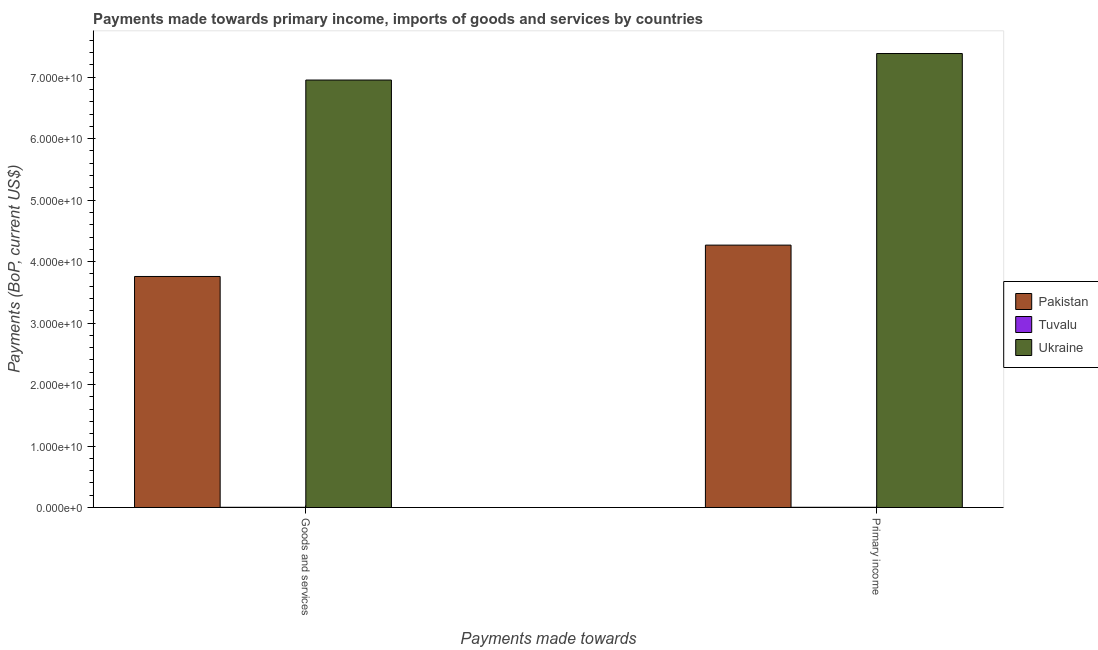How many different coloured bars are there?
Ensure brevity in your answer.  3. Are the number of bars per tick equal to the number of legend labels?
Provide a succinct answer. Yes. How many bars are there on the 1st tick from the left?
Make the answer very short. 3. What is the label of the 1st group of bars from the left?
Provide a succinct answer. Goods and services. What is the payments made towards primary income in Ukraine?
Provide a short and direct response. 7.39e+1. Across all countries, what is the maximum payments made towards goods and services?
Offer a terse response. 6.95e+1. Across all countries, what is the minimum payments made towards primary income?
Offer a very short reply. 3.24e+07. In which country was the payments made towards goods and services maximum?
Provide a succinct answer. Ukraine. In which country was the payments made towards primary income minimum?
Offer a terse response. Tuvalu. What is the total payments made towards goods and services in the graph?
Make the answer very short. 1.07e+11. What is the difference between the payments made towards primary income in Tuvalu and that in Pakistan?
Make the answer very short. -4.27e+1. What is the difference between the payments made towards goods and services in Tuvalu and the payments made towards primary income in Ukraine?
Make the answer very short. -7.38e+1. What is the average payments made towards primary income per country?
Your response must be concise. 3.89e+1. What is the difference between the payments made towards primary income and payments made towards goods and services in Tuvalu?
Your answer should be compact. 7.97e+05. What is the ratio of the payments made towards primary income in Pakistan to that in Tuvalu?
Your answer should be very brief. 1316.66. Is the payments made towards primary income in Tuvalu less than that in Ukraine?
Offer a very short reply. Yes. What does the 3rd bar from the left in Goods and services represents?
Give a very brief answer. Ukraine. What does the 1st bar from the right in Goods and services represents?
Your answer should be very brief. Ukraine. How many countries are there in the graph?
Your response must be concise. 3. What is the difference between two consecutive major ticks on the Y-axis?
Your response must be concise. 1.00e+1. Are the values on the major ticks of Y-axis written in scientific E-notation?
Your response must be concise. Yes. Does the graph contain any zero values?
Ensure brevity in your answer.  No. Does the graph contain grids?
Provide a succinct answer. No. How many legend labels are there?
Ensure brevity in your answer.  3. What is the title of the graph?
Your answer should be very brief. Payments made towards primary income, imports of goods and services by countries. Does "St. Kitts and Nevis" appear as one of the legend labels in the graph?
Ensure brevity in your answer.  No. What is the label or title of the X-axis?
Offer a terse response. Payments made towards. What is the label or title of the Y-axis?
Keep it short and to the point. Payments (BoP, current US$). What is the Payments (BoP, current US$) in Pakistan in Goods and services?
Offer a terse response. 3.76e+1. What is the Payments (BoP, current US$) in Tuvalu in Goods and services?
Keep it short and to the point. 3.16e+07. What is the Payments (BoP, current US$) in Ukraine in Goods and services?
Ensure brevity in your answer.  6.95e+1. What is the Payments (BoP, current US$) in Pakistan in Primary income?
Make the answer very short. 4.27e+1. What is the Payments (BoP, current US$) of Tuvalu in Primary income?
Offer a very short reply. 3.24e+07. What is the Payments (BoP, current US$) in Ukraine in Primary income?
Keep it short and to the point. 7.39e+1. Across all Payments made towards, what is the maximum Payments (BoP, current US$) of Pakistan?
Ensure brevity in your answer.  4.27e+1. Across all Payments made towards, what is the maximum Payments (BoP, current US$) in Tuvalu?
Your answer should be compact. 3.24e+07. Across all Payments made towards, what is the maximum Payments (BoP, current US$) in Ukraine?
Ensure brevity in your answer.  7.39e+1. Across all Payments made towards, what is the minimum Payments (BoP, current US$) of Pakistan?
Give a very brief answer. 3.76e+1. Across all Payments made towards, what is the minimum Payments (BoP, current US$) of Tuvalu?
Provide a short and direct response. 3.16e+07. Across all Payments made towards, what is the minimum Payments (BoP, current US$) of Ukraine?
Keep it short and to the point. 6.95e+1. What is the total Payments (BoP, current US$) in Pakistan in the graph?
Give a very brief answer. 8.03e+1. What is the total Payments (BoP, current US$) of Tuvalu in the graph?
Provide a succinct answer. 6.40e+07. What is the total Payments (BoP, current US$) in Ukraine in the graph?
Ensure brevity in your answer.  1.43e+11. What is the difference between the Payments (BoP, current US$) in Pakistan in Goods and services and that in Primary income?
Make the answer very short. -5.10e+09. What is the difference between the Payments (BoP, current US$) of Tuvalu in Goods and services and that in Primary income?
Give a very brief answer. -7.97e+05. What is the difference between the Payments (BoP, current US$) of Ukraine in Goods and services and that in Primary income?
Provide a short and direct response. -4.32e+09. What is the difference between the Payments (BoP, current US$) in Pakistan in Goods and services and the Payments (BoP, current US$) in Tuvalu in Primary income?
Keep it short and to the point. 3.76e+1. What is the difference between the Payments (BoP, current US$) of Pakistan in Goods and services and the Payments (BoP, current US$) of Ukraine in Primary income?
Your response must be concise. -3.63e+1. What is the difference between the Payments (BoP, current US$) in Tuvalu in Goods and services and the Payments (BoP, current US$) in Ukraine in Primary income?
Provide a succinct answer. -7.38e+1. What is the average Payments (BoP, current US$) in Pakistan per Payments made towards?
Your response must be concise. 4.01e+1. What is the average Payments (BoP, current US$) in Tuvalu per Payments made towards?
Offer a terse response. 3.20e+07. What is the average Payments (BoP, current US$) of Ukraine per Payments made towards?
Provide a succinct answer. 7.17e+1. What is the difference between the Payments (BoP, current US$) in Pakistan and Payments (BoP, current US$) in Tuvalu in Goods and services?
Provide a short and direct response. 3.76e+1. What is the difference between the Payments (BoP, current US$) in Pakistan and Payments (BoP, current US$) in Ukraine in Goods and services?
Keep it short and to the point. -3.20e+1. What is the difference between the Payments (BoP, current US$) of Tuvalu and Payments (BoP, current US$) of Ukraine in Goods and services?
Provide a succinct answer. -6.95e+1. What is the difference between the Payments (BoP, current US$) in Pakistan and Payments (BoP, current US$) in Tuvalu in Primary income?
Offer a terse response. 4.27e+1. What is the difference between the Payments (BoP, current US$) of Pakistan and Payments (BoP, current US$) of Ukraine in Primary income?
Make the answer very short. -3.12e+1. What is the difference between the Payments (BoP, current US$) in Tuvalu and Payments (BoP, current US$) in Ukraine in Primary income?
Make the answer very short. -7.38e+1. What is the ratio of the Payments (BoP, current US$) of Pakistan in Goods and services to that in Primary income?
Offer a terse response. 0.88. What is the ratio of the Payments (BoP, current US$) of Tuvalu in Goods and services to that in Primary income?
Your answer should be compact. 0.98. What is the ratio of the Payments (BoP, current US$) of Ukraine in Goods and services to that in Primary income?
Keep it short and to the point. 0.94. What is the difference between the highest and the second highest Payments (BoP, current US$) of Pakistan?
Give a very brief answer. 5.10e+09. What is the difference between the highest and the second highest Payments (BoP, current US$) in Tuvalu?
Offer a very short reply. 7.97e+05. What is the difference between the highest and the second highest Payments (BoP, current US$) in Ukraine?
Offer a terse response. 4.32e+09. What is the difference between the highest and the lowest Payments (BoP, current US$) in Pakistan?
Your answer should be compact. 5.10e+09. What is the difference between the highest and the lowest Payments (BoP, current US$) in Tuvalu?
Ensure brevity in your answer.  7.97e+05. What is the difference between the highest and the lowest Payments (BoP, current US$) of Ukraine?
Provide a short and direct response. 4.32e+09. 